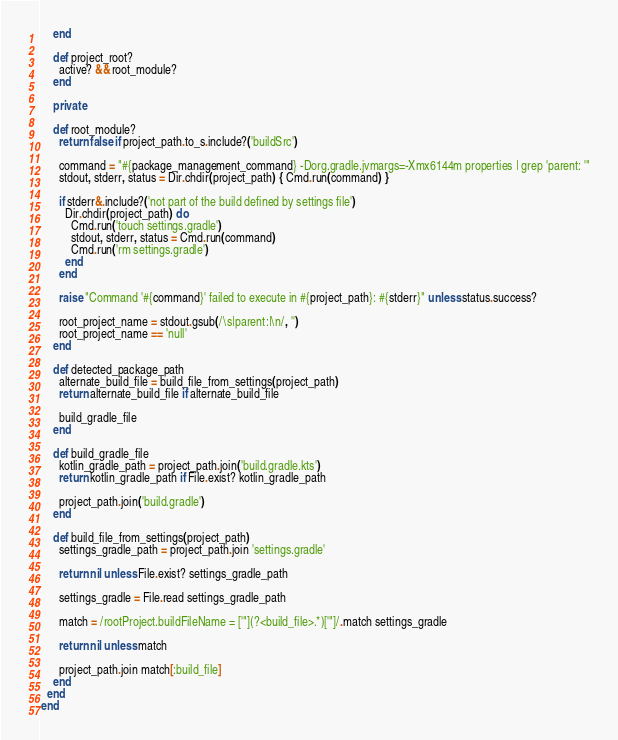Convert code to text. <code><loc_0><loc_0><loc_500><loc_500><_Ruby_>    end

    def project_root?
      active? && root_module?
    end

    private

    def root_module?
      return false if project_path.to_s.include?('buildSrc')

      command = "#{package_management_command} -Dorg.gradle.jvmargs=-Xmx6144m properties | grep 'parent: '"
      stdout, stderr, status = Dir.chdir(project_path) { Cmd.run(command) }

      if stderr&.include?('not part of the build defined by settings file')
        Dir.chdir(project_path) do
          Cmd.run('touch settings.gradle')
          stdout, stderr, status = Cmd.run(command)
          Cmd.run('rm settings.gradle')
        end
      end

      raise "Command '#{command}' failed to execute in #{project_path}: #{stderr}" unless status.success?

      root_project_name = stdout.gsub(/\s|parent:|\n/, '')
      root_project_name == 'null'
    end

    def detected_package_path
      alternate_build_file = build_file_from_settings(project_path)
      return alternate_build_file if alternate_build_file

      build_gradle_file
    end

    def build_gradle_file
      kotlin_gradle_path = project_path.join('build.gradle.kts')
      return kotlin_gradle_path if File.exist? kotlin_gradle_path

      project_path.join('build.gradle')
    end

    def build_file_from_settings(project_path)
      settings_gradle_path = project_path.join 'settings.gradle'

      return nil unless File.exist? settings_gradle_path

      settings_gradle = File.read settings_gradle_path

      match = /rootProject.buildFileName = ['"](?<build_file>.*)['"]/.match settings_gradle

      return nil unless match

      project_path.join match[:build_file]
    end
  end
end
</code> 